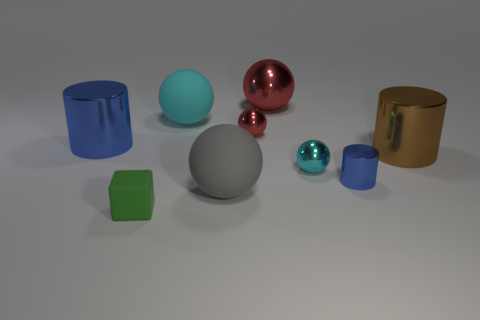Subtract all large cyan spheres. How many spheres are left? 4 Subtract all gray spheres. How many spheres are left? 4 Subtract all brown spheres. Subtract all blue blocks. How many spheres are left? 5 Subtract all cylinders. How many objects are left? 6 Add 3 big red balls. How many big red balls are left? 4 Add 3 tiny red rubber blocks. How many tiny red rubber blocks exist? 3 Subtract 0 purple cylinders. How many objects are left? 9 Subtract all tiny cylinders. Subtract all big brown metal things. How many objects are left? 7 